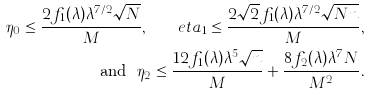Convert formula to latex. <formula><loc_0><loc_0><loc_500><loc_500>\eta _ { 0 } \leq \frac { 2 f _ { 1 } ( \lambda ) \lambda ^ { 7 / 2 } \sqrt { N } } { M } , \quad e t a _ { 1 } \leq \frac { 2 \sqrt { 2 } f _ { 1 } ( \lambda ) \lambda ^ { 7 / 2 } \sqrt { N n } } { M } , \\ \ \text { and } \ \eta _ { 2 } \leq \frac { 1 2 f _ { 1 } ( \lambda ) \lambda ^ { 5 } \sqrt { n } } { M } + \frac { 8 f _ { 2 } ( \lambda ) \lambda ^ { 7 } N } { M ^ { 2 } } .</formula> 